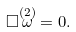<formula> <loc_0><loc_0><loc_500><loc_500>\Box \overset { ( 2 ) } { \omega } = 0 .</formula> 